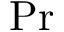Convert formula to latex. <formula><loc_0><loc_0><loc_500><loc_500>P r</formula> 